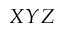<formula> <loc_0><loc_0><loc_500><loc_500>X Y Z</formula> 